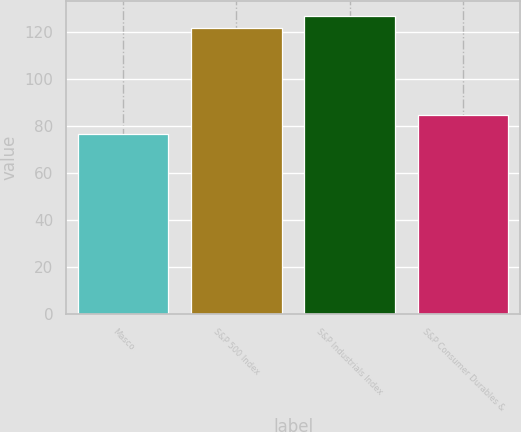<chart> <loc_0><loc_0><loc_500><loc_500><bar_chart><fcel>Masco<fcel>S&P 500 Index<fcel>S&P Industrials Index<fcel>S&P Consumer Durables &<nl><fcel>76.74<fcel>121.95<fcel>126.95<fcel>84.5<nl></chart> 